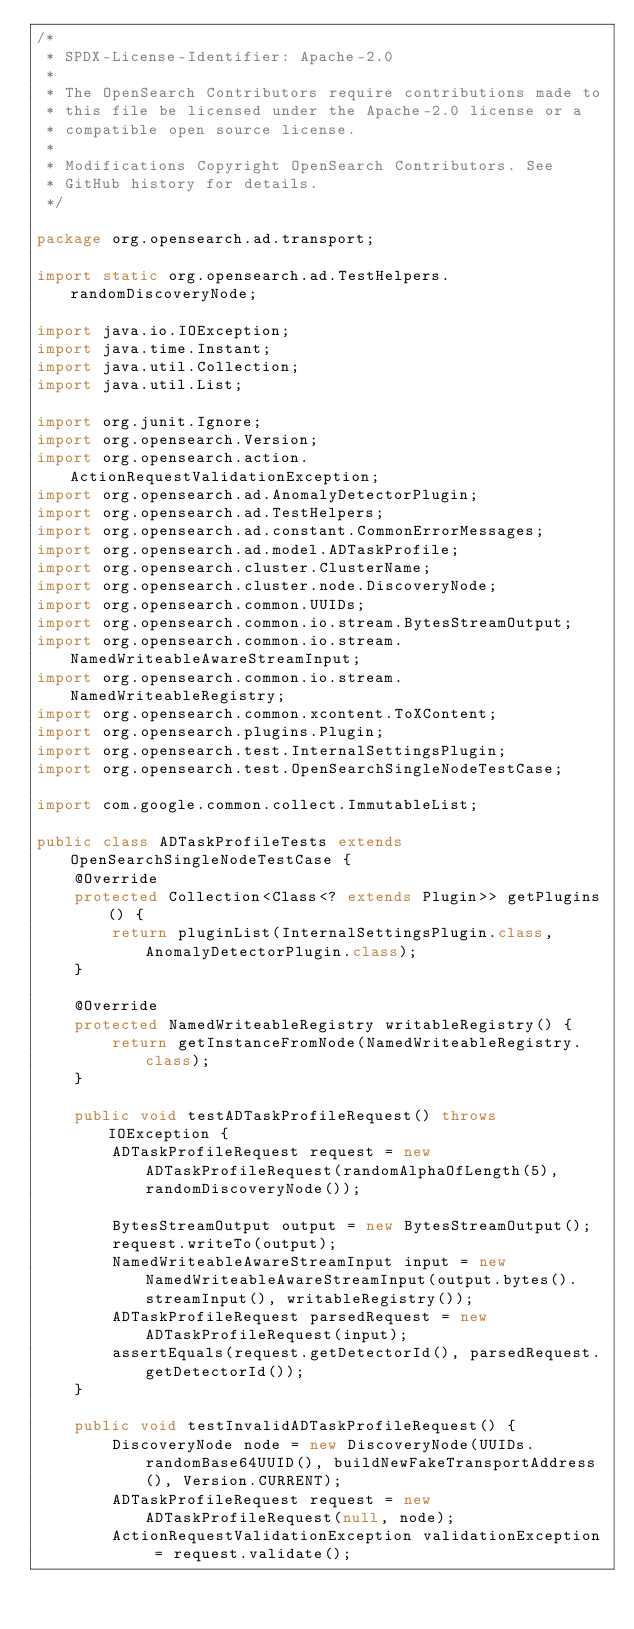<code> <loc_0><loc_0><loc_500><loc_500><_Java_>/*
 * SPDX-License-Identifier: Apache-2.0
 *
 * The OpenSearch Contributors require contributions made to
 * this file be licensed under the Apache-2.0 license or a
 * compatible open source license.
 *
 * Modifications Copyright OpenSearch Contributors. See
 * GitHub history for details.
 */

package org.opensearch.ad.transport;

import static org.opensearch.ad.TestHelpers.randomDiscoveryNode;

import java.io.IOException;
import java.time.Instant;
import java.util.Collection;
import java.util.List;

import org.junit.Ignore;
import org.opensearch.Version;
import org.opensearch.action.ActionRequestValidationException;
import org.opensearch.ad.AnomalyDetectorPlugin;
import org.opensearch.ad.TestHelpers;
import org.opensearch.ad.constant.CommonErrorMessages;
import org.opensearch.ad.model.ADTaskProfile;
import org.opensearch.cluster.ClusterName;
import org.opensearch.cluster.node.DiscoveryNode;
import org.opensearch.common.UUIDs;
import org.opensearch.common.io.stream.BytesStreamOutput;
import org.opensearch.common.io.stream.NamedWriteableAwareStreamInput;
import org.opensearch.common.io.stream.NamedWriteableRegistry;
import org.opensearch.common.xcontent.ToXContent;
import org.opensearch.plugins.Plugin;
import org.opensearch.test.InternalSettingsPlugin;
import org.opensearch.test.OpenSearchSingleNodeTestCase;

import com.google.common.collect.ImmutableList;

public class ADTaskProfileTests extends OpenSearchSingleNodeTestCase {
    @Override
    protected Collection<Class<? extends Plugin>> getPlugins() {
        return pluginList(InternalSettingsPlugin.class, AnomalyDetectorPlugin.class);
    }

    @Override
    protected NamedWriteableRegistry writableRegistry() {
        return getInstanceFromNode(NamedWriteableRegistry.class);
    }

    public void testADTaskProfileRequest() throws IOException {
        ADTaskProfileRequest request = new ADTaskProfileRequest(randomAlphaOfLength(5), randomDiscoveryNode());

        BytesStreamOutput output = new BytesStreamOutput();
        request.writeTo(output);
        NamedWriteableAwareStreamInput input = new NamedWriteableAwareStreamInput(output.bytes().streamInput(), writableRegistry());
        ADTaskProfileRequest parsedRequest = new ADTaskProfileRequest(input);
        assertEquals(request.getDetectorId(), parsedRequest.getDetectorId());
    }

    public void testInvalidADTaskProfileRequest() {
        DiscoveryNode node = new DiscoveryNode(UUIDs.randomBase64UUID(), buildNewFakeTransportAddress(), Version.CURRENT);
        ADTaskProfileRequest request = new ADTaskProfileRequest(null, node);
        ActionRequestValidationException validationException = request.validate();</code> 